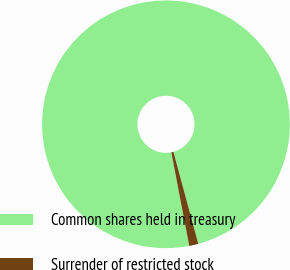Convert chart. <chart><loc_0><loc_0><loc_500><loc_500><pie_chart><fcel>Common shares held in treasury<fcel>Surrender of restricted stock<nl><fcel>98.81%<fcel>1.19%<nl></chart> 